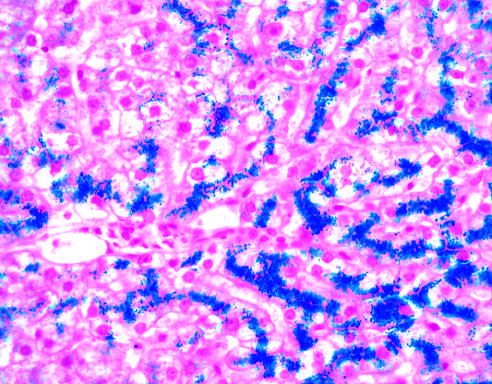how is the parenchymal architecture of disease, even with such abundant iron?
Answer the question using a single word or phrase. Normal at this stage of disease 